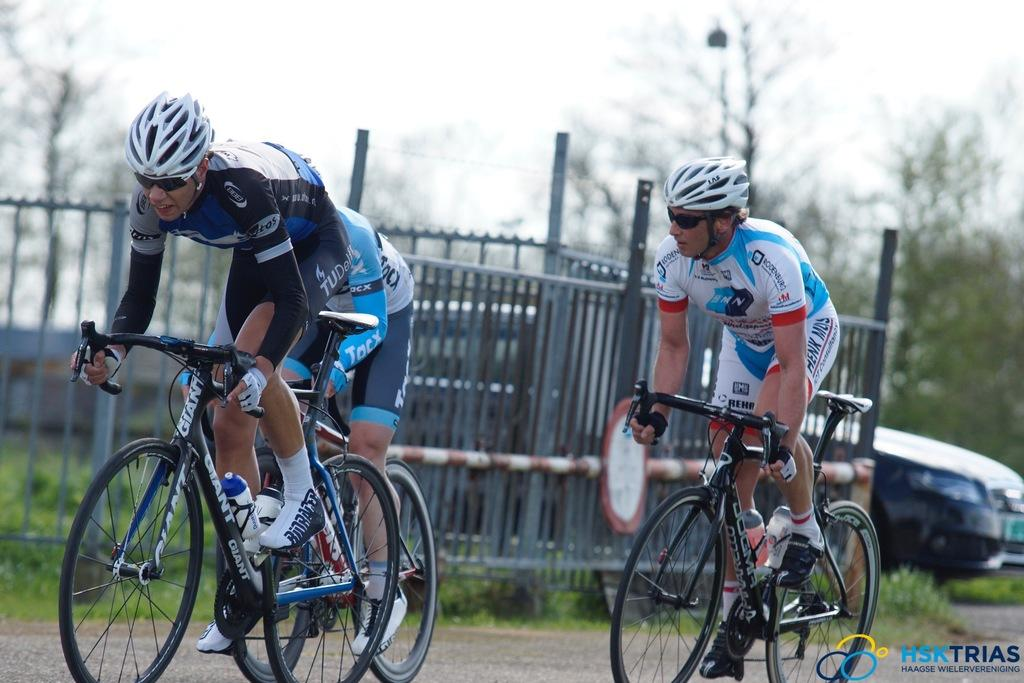How many men are in the image? There are three men in the image. What are the men doing in the image? The men are cycling on a road. What can be seen in the background of the image? There is a fencing, a car, and trees in the background of the image. Where is the text located in the image? The text is in the bottom right corner of the image. What type of riddle is the man in the middle of the image trying to solve? There is no indication in the image that the men are trying to solve a riddle. What gold object can be seen in the image? There is no gold object present in the image. 